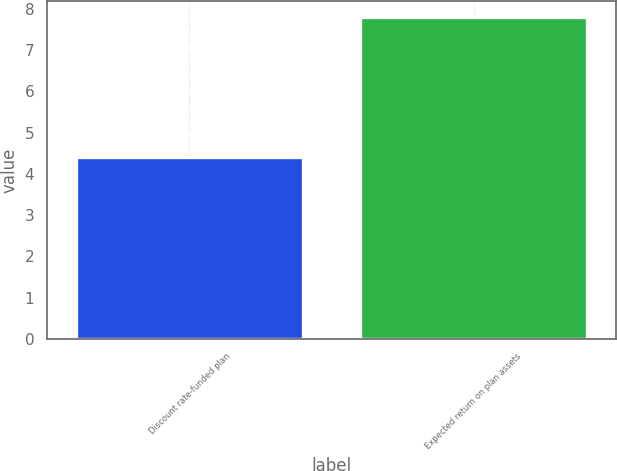Convert chart to OTSL. <chart><loc_0><loc_0><loc_500><loc_500><bar_chart><fcel>Discount rate-funded plan<fcel>Expected return on plan assets<nl><fcel>4.4<fcel>7.8<nl></chart> 